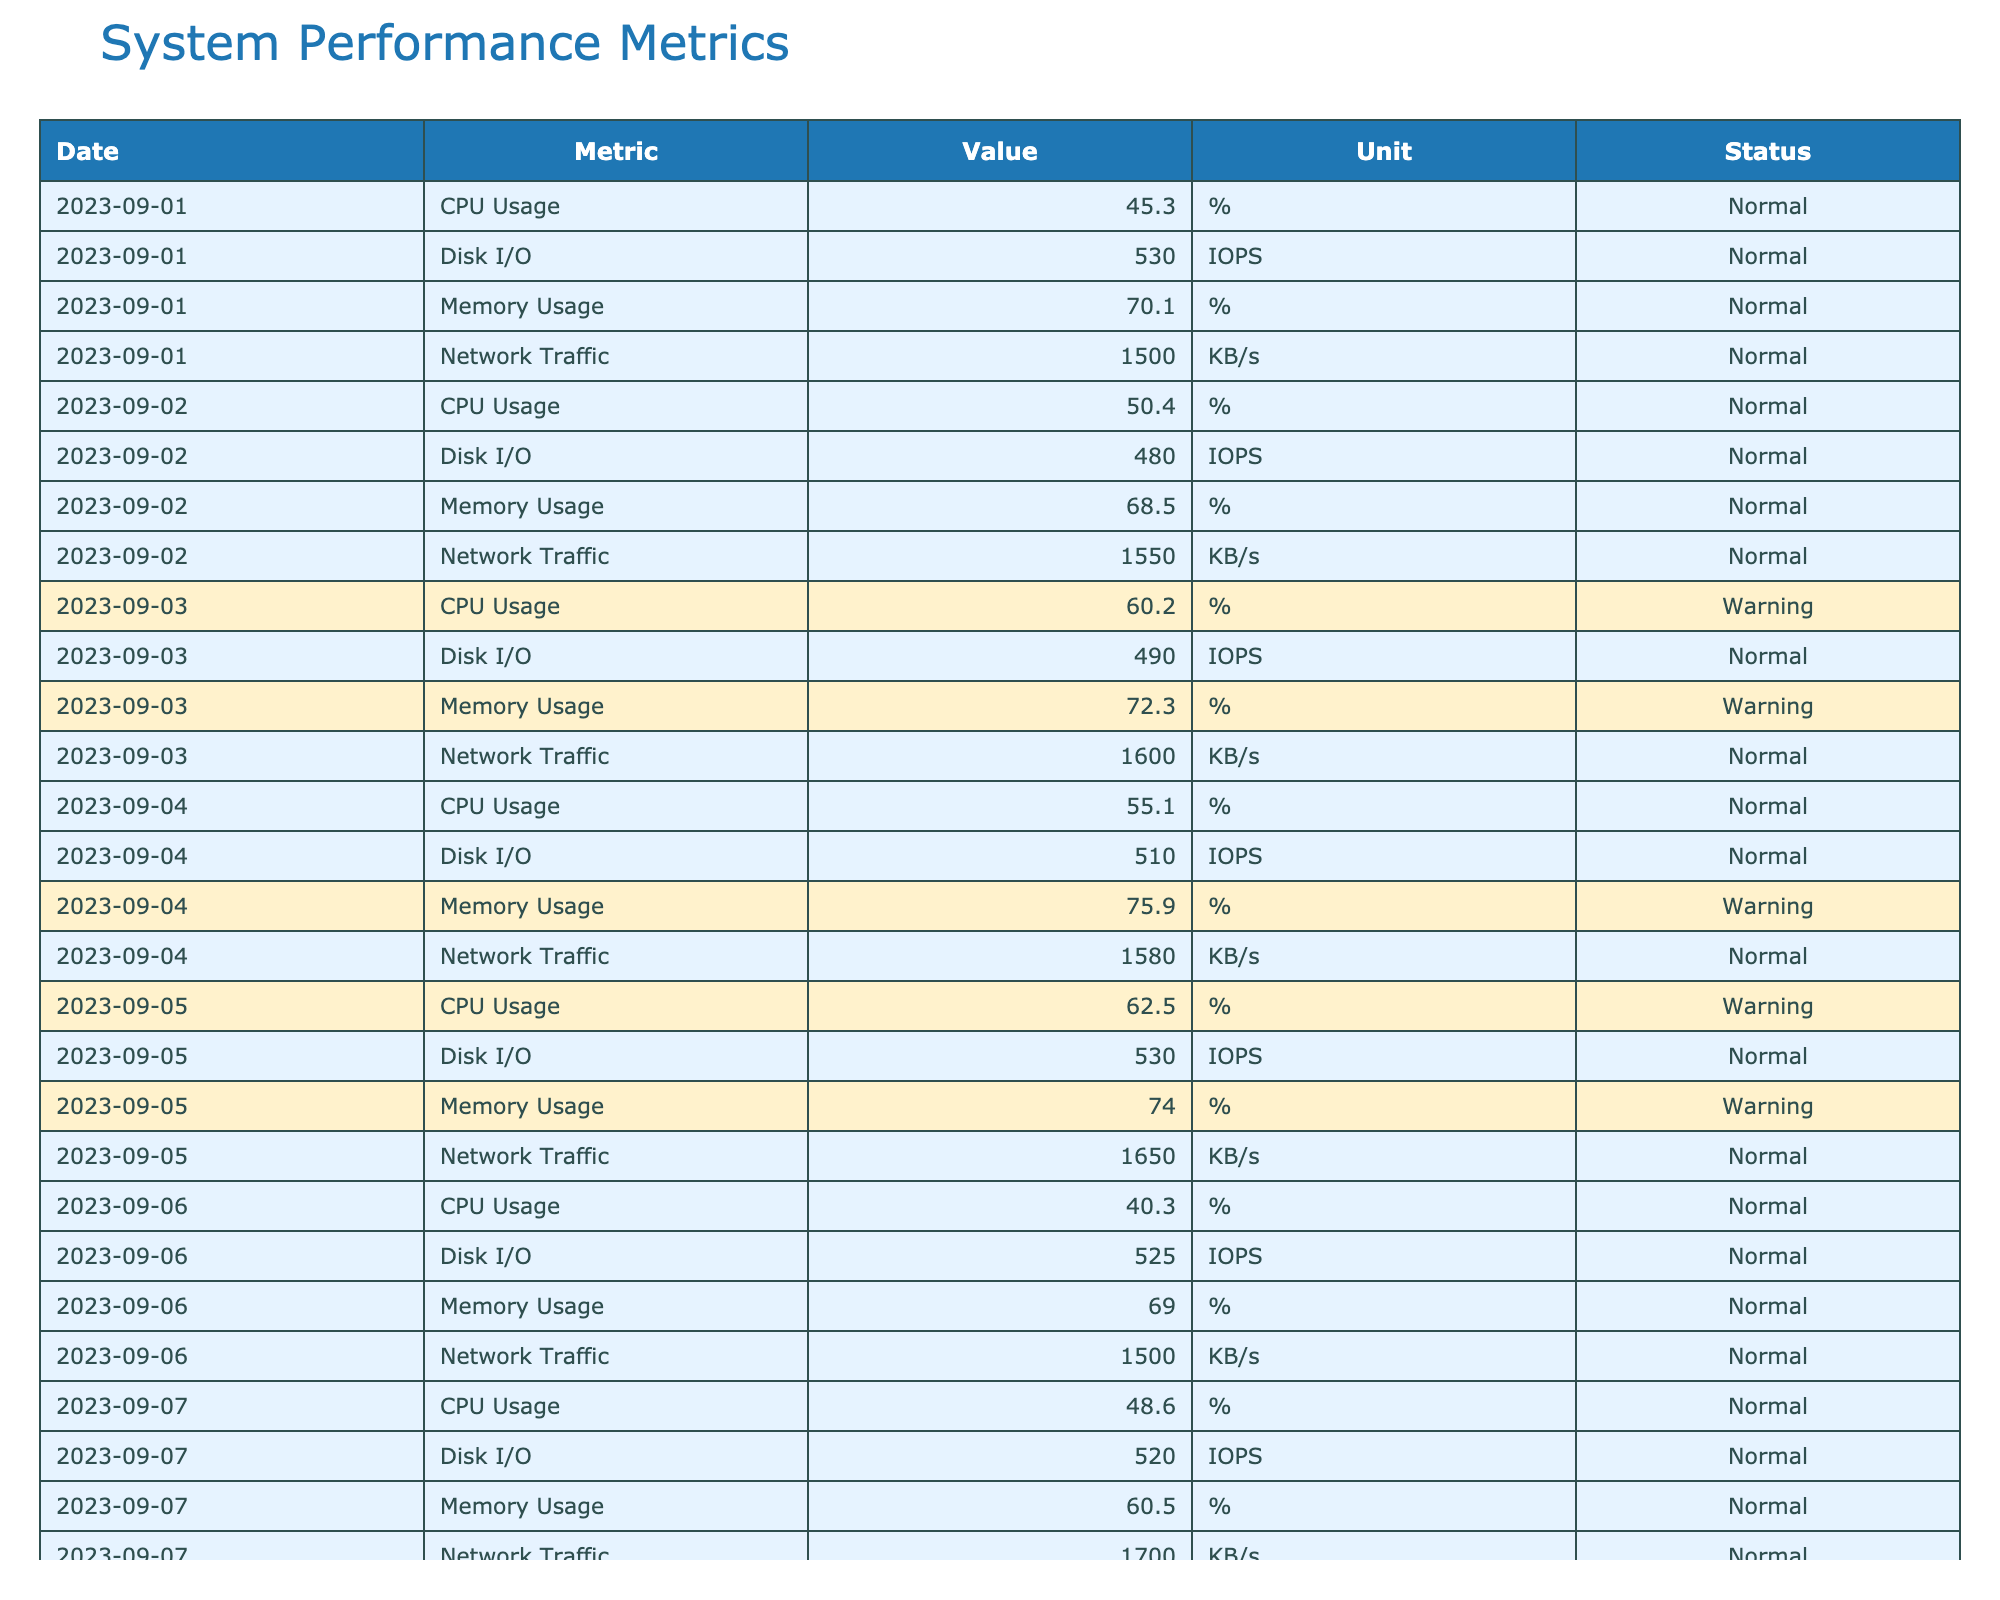What is the highest CPU Usage recorded in the last 30 days? By scanning the "Value" column under the "CPU Usage" metric, the highest recorded value is 64.8% on 2023-09-09.
Answer: 64.8% How many days were there with "Critical" Memory Usage? In the "Status" column for "Memory Usage," there are three entries with the status "Critical," occurring on 2023-09-09, 2023-09-12, and 2023-09-20.
Answer: 3 What was the average Disk I/O over the last 30 days? By summing the Disk I/O values (sum = 540 + 530 + ... + 480) and dividing by the number of records (30 days), the total Disk I/O values sum to 15677 and the average is 15677 / 30 = 522.57.
Answer: 522.57 IOPS Was there a day where both CPU Usage and Memory Usage were "Warning"? A scan of the table shows 10 entries where both CPU Usage and Memory Usage have the status "Warning," specifically on 2023-09-03, 2023-09-05, 2023-09-08, 2023-09-11, 2023-09-12, 2023-09-16, 2023-09-20, 2023-09-21, 2023-09-22, and 2023-09-25.
Answer: Yes What was the trend of Network Traffic over the last 30 days? By analyzing the daily values of Network Traffic, there are fluctuations but overall, there's an increasing trend from 1500 KB/s on 2023-09-01 to a peak of 1900 KB/s on 2023-09-09, followed by some decrease and stabilization around 1300-1800 KB/s towards the end of the month.
Answer: Increasing trend with fluctuations Which metric had the most "Warning" days, and how many? The metrics with "Warning" status on multiple days are: CPU Usage (11 days) and Memory Usage (10 days); hence, CPU Usage had the most "Warning" days.
Answer: CPU Usage with 11 days On which date was Disk I/O at its highest, and what was the value? Upon reviewing the table, the highest value for Disk I/O is 550 IOPS recorded on 2023-09-20.
Answer: 550 IOPS on 2023-09-20 What percentage of the days experienced "Normal" status for CPU Usage? Out of the 30 days, 19 days had "Normal" CPU Usage status, which means that (19/30)*100 = 63.33%.
Answer: 63.33% Did Memory Usage maintain a "Normal" status in the last week of September? By checking the last week entries (from 2023-09-24 to 2023-09-30), it shows that on 25th, 26th, and 30th, "Memory Usage" was "Warning," thus it did not maintain a "Normal" status.
Answer: No Calculate the total Network Traffic reported over the entire month. Summing all the daily network traffic values (the summation equals to 47100 KB) yields the total network traffic for the month.
Answer: 47100 KB 